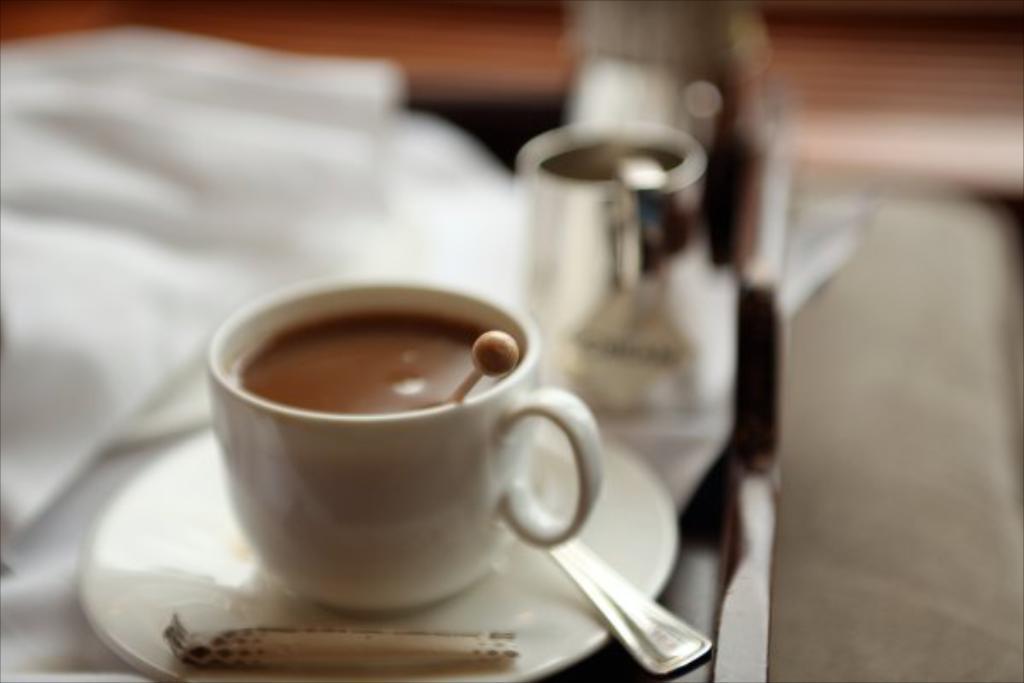Describe this image in one or two sentences. In this image there is a cup and a saucer. The cup is filled with drink and a stick is in it. Right side a cup is on the table having a cloth. Background is blurry. 